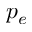<formula> <loc_0><loc_0><loc_500><loc_500>p _ { e }</formula> 